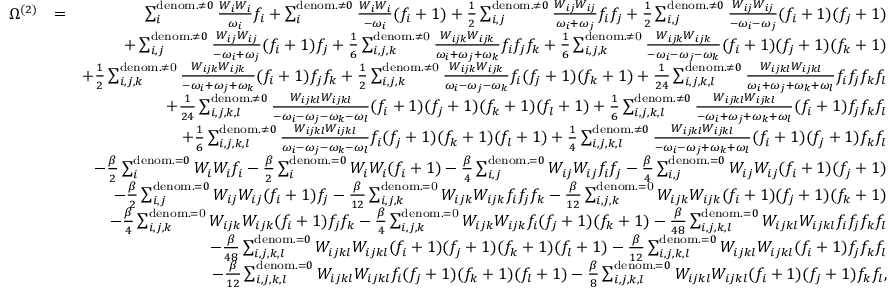Convert formula to latex. <formula><loc_0><loc_0><loc_500><loc_500>\begin{array} { r l r } { \Omega ^ { ( 2 ) } } & { = } & { \sum _ { i } ^ { d e n o m . \neq 0 } \frac { W _ { i } W _ { i } } { \omega _ { i } } f _ { i } + \sum _ { i } ^ { d e n o m . \neq 0 } \frac { W _ { i } W _ { i } } { - \omega _ { i } } ( f _ { i } + 1 ) + \frac { 1 } { 2 } \sum _ { i , j } ^ { d e n o m . \neq 0 } \frac { W _ { i j } W _ { i j } } { \omega _ { i } + \omega _ { j } } f _ { i } f _ { j } + \frac { 1 } { 2 } \sum _ { i , j } ^ { d e n o m . \neq 0 } \frac { W _ { i j } W _ { i j } } { - \omega _ { i } - \omega _ { j } } ( f _ { i } + 1 ) ( f _ { j } + 1 ) } \\ & { + \sum _ { i , j } ^ { d e n o m . \neq 0 } \frac { W _ { i j } W _ { i j } } { - \omega _ { i } + \omega _ { j } } ( f _ { i } + 1 ) f _ { j } + \frac { 1 } { 6 } \sum _ { i , j , k } ^ { d e n o m . \neq 0 } \frac { W _ { i j k } W _ { i j k } } { \omega _ { i } + \omega _ { j } + \omega _ { k } } f _ { i } f _ { j } f _ { k } + \frac { 1 } { 6 } \sum _ { i , j , k } ^ { d e n o m . \neq 0 } \frac { W _ { i j k } W _ { i j k } } { - \omega _ { i } - \omega _ { j } - \omega _ { k } } ( f _ { i } + 1 ) ( f _ { j } + 1 ) ( f _ { k } + 1 ) } \\ & { + \frac { 1 } { 2 } \sum _ { i , j , k } ^ { d e n o m . \neq 0 } \frac { W _ { i j k } W _ { i j k } } { - \omega _ { i } + \omega _ { j } + \omega _ { k } } ( f _ { i } + 1 ) f _ { j } f _ { k } + \frac { 1 } { 2 } \sum _ { i , j , k } ^ { d e n o m . \neq 0 } \frac { W _ { i j k } W _ { i j k } } { \omega _ { i } - \omega _ { j } - \omega _ { k } } f _ { i } ( f _ { j } + 1 ) ( f _ { k } + 1 ) + \frac { 1 } { 2 4 } \sum _ { i , j , k , l } ^ { d e n o m . \neq 0 } \frac { W _ { i j k l } W _ { i j k l } } { \omega _ { i } + \omega _ { j } + \omega _ { k } + \omega _ { l } } f _ { i } f _ { j } f _ { k } f _ { l } } \\ & { + \frac { 1 } { 2 4 } \sum _ { i , j , k , l } ^ { d e n o m . \neq 0 } \frac { W _ { i j k l } W _ { i j k l } } { - \omega _ { i } - \omega _ { j } - \omega _ { k } - \omega _ { l } } ( f _ { i } + 1 ) ( f _ { j } + 1 ) ( f _ { k } + 1 ) ( f _ { l } + 1 ) + \frac { 1 } { 6 } \sum _ { i , j , k , l } ^ { d e n o m . \neq 0 } \frac { W _ { i j k l } W _ { i j k l } } { - \omega _ { i } + \omega _ { j } + \omega _ { k } + \omega _ { l } } ( f _ { i } + 1 ) f _ { j } f _ { k } f _ { l } } \\ & { + \frac { 1 } { 6 } \sum _ { i , j , k , l } ^ { d e n o m . \neq 0 } \frac { W _ { i j k l } W _ { i j k l } } { \omega _ { i } - \omega _ { j } - \omega _ { k } - \omega _ { l } } f _ { i } ( f _ { j } + 1 ) ( f _ { k } + 1 ) ( f _ { l } + 1 ) + \frac { 1 } { 4 } \sum _ { i , j , k , l } ^ { d e n o m . \neq 0 } \frac { W _ { i j k l } W _ { i j k l } } { - \omega _ { i } - \omega _ { j } + \omega _ { k } + \omega _ { l } } ( f _ { i } + 1 ) ( f _ { j } + 1 ) f _ { k } f _ { l } } \\ & { - \frac { \beta } { 2 } \sum _ { i } ^ { d e n o m . = 0 } W _ { i } W _ { i } { f _ { i } } - \frac { \beta } { 2 } \sum _ { i } ^ { d e n o m . = 0 } W _ { i } W _ { i } { ( f _ { i } + 1 } ) - \frac { \beta } { 4 } \sum _ { i , j } ^ { d e n o m . = 0 } W _ { i j } W _ { i j } f _ { i } f _ { j } - \frac { \beta } { 4 } \sum _ { i , j } ^ { d e n o m . = 0 } W _ { i j } W _ { i j } ( f _ { i } + 1 ) ( f _ { j } + 1 ) } \\ & { - \frac { \beta } { 2 } \sum _ { i , j } ^ { d e n o m . = 0 } W _ { i j } W _ { i j } { ( f _ { i } + 1 ) f _ { j } } - \frac { \beta } { 1 2 } \sum _ { i , j , k } ^ { d e n o m . = 0 } W _ { i j k } W _ { i j k } { f _ { i } f _ { j } f _ { k } } - \frac { \beta } { 1 2 } \sum _ { i , j , k } ^ { d e n o m . = 0 } W _ { i j k } W _ { i j k } { ( f _ { i } + 1 ) ( f _ { j } + 1 ) ( f _ { k } + 1 ) } } \\ & { - \frac { \beta } { 4 } \sum _ { i , j , k } ^ { d e n o m . = 0 } W _ { i j k } W _ { i j k } { ( f _ { i } + 1 ) f _ { j } f _ { k } } - \frac { \beta } { 4 } \sum _ { i , j , k } ^ { d e n o m . = 0 } W _ { i j k } W _ { i j k } { f _ { i } ( f _ { j } + 1 ) ( f _ { k } + 1 ) } - \frac { \beta } { 4 8 } \sum _ { i , j , k , l } ^ { d e n o m . = 0 } W _ { i j k l } W _ { i j k l } f _ { i } f _ { j } f _ { k } f _ { l } } \\ & { - \frac { \beta } { 4 8 } \sum _ { i , j , k , l } ^ { d e n o m . = 0 } W _ { i j k l } W _ { i j k l } ( f _ { i } + 1 ) ( f _ { j } + 1 ) ( f _ { k } + 1 ) ( f _ { l } + 1 ) - \frac { \beta } { 1 2 } \sum _ { i , j , k , l } ^ { d e n o m . = 0 } W _ { i j k l } W _ { i j k l } ( f _ { i } + 1 ) f _ { j } f _ { k } f _ { l } } \\ & { - \frac { \beta } { 1 2 } \sum _ { i , j , k , l } ^ { d e n o m . = 0 } W _ { i j k l } W _ { i j k l } f _ { i } ( f _ { j } + 1 ) ( f _ { k } + 1 ) ( f _ { l } + 1 ) - \frac { \beta } { 8 } \sum _ { i , j , k , l } ^ { d e n o m . = 0 } W _ { i j k l } W _ { i j k l } ( f _ { i } + 1 ) ( f _ { j } + 1 ) f _ { k } f _ { l } , } \end{array}</formula> 